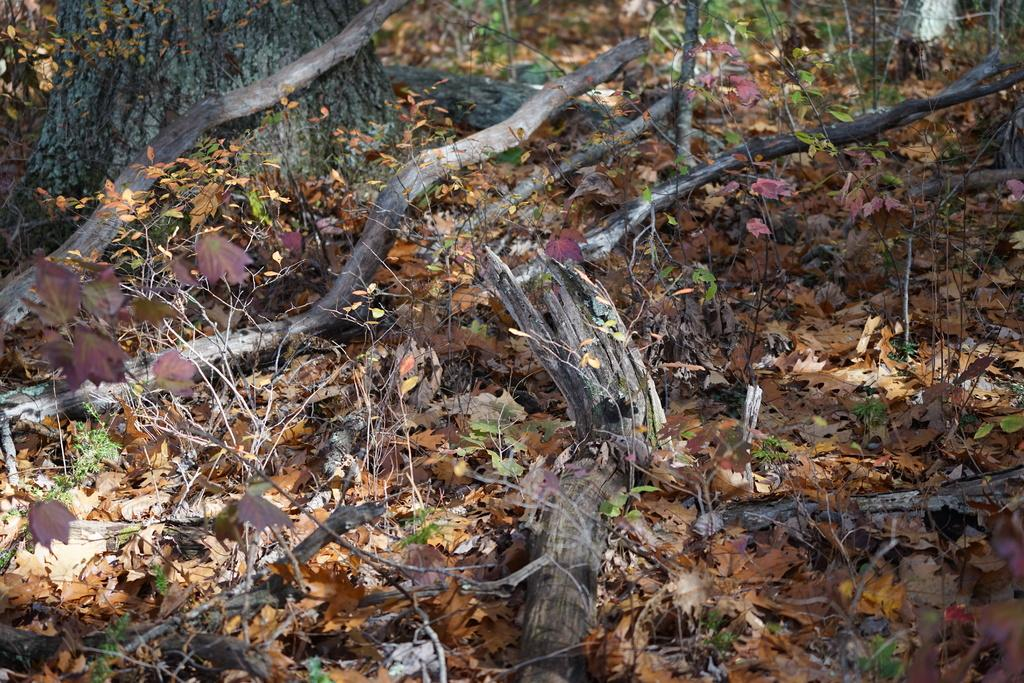What type of vegetation is present in the image? There is a tree, dry leaves, branches, twigs, and plants in the picture. Can you describe the tree in the image? The tree has branches and dry leaves in the image. What other elements can be seen in the picture besides the tree? There are twigs and other plants visible in the image. What type of cake is being served in the class in the image? There is no class or cake present in the image; it features a tree and other plant elements. 